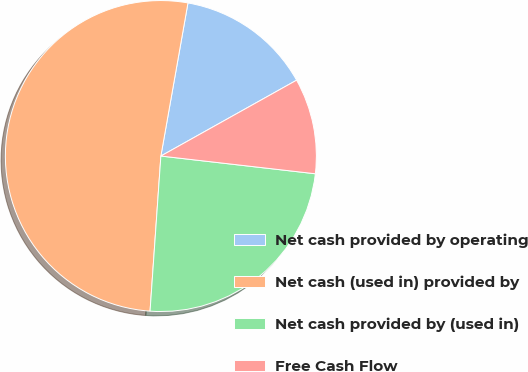<chart> <loc_0><loc_0><loc_500><loc_500><pie_chart><fcel>Net cash provided by operating<fcel>Net cash (used in) provided by<fcel>Net cash provided by (used in)<fcel>Free Cash Flow<nl><fcel>14.1%<fcel>51.68%<fcel>24.29%<fcel>9.93%<nl></chart> 